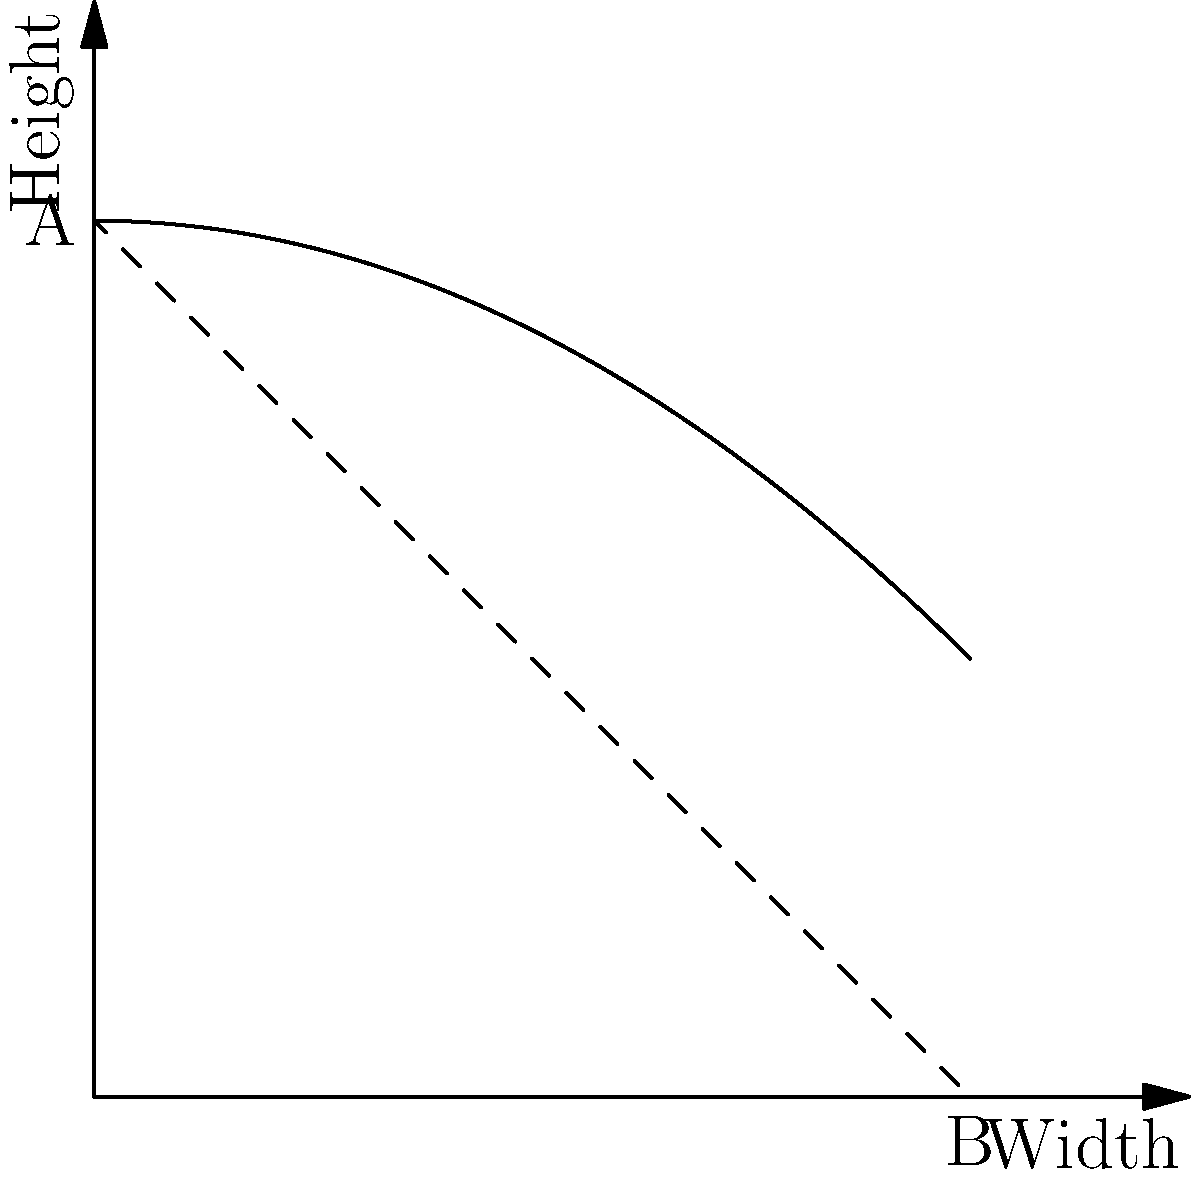As a captain assessing recruits' understanding of fluid mechanics, you present them with a diagram of a container filled with a liquid. The container has a triangular cross-section, with side A being 2 units tall and side B being 2 units wide. What is the ratio of the pressure at the bottom center of the container to the pressure at the midpoint of side A? To solve this problem, we'll follow these steps:

1. Recall the hydrostatic pressure equation: $P = \rho gh$, where $\rho$ is fluid density, $g$ is gravitational acceleration, and $h$ is depth.

2. Identify the depths:
   - At the bottom center: $h_1 = 2$ units
   - At the midpoint of side A: $h_2 = 1$ unit

3. Set up the ratio of pressures:
   $\frac{P_1}{P_2} = \frac{\rho gh_1}{\rho gh_2}$

4. The $\rho$ and $g$ terms cancel out, leaving:
   $\frac{P_1}{P_2} = \frac{h_1}{h_2} = \frac{2}{1} = 2$

5. Therefore, the pressure at the bottom center is twice the pressure at the midpoint of side A.
Answer: 2:1 